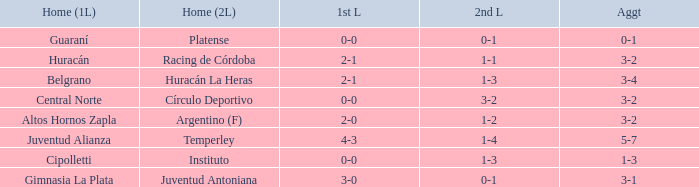What was the score of the 2nd leg when the Belgrano played the first leg at home with a score of 2-1? 1-3. 